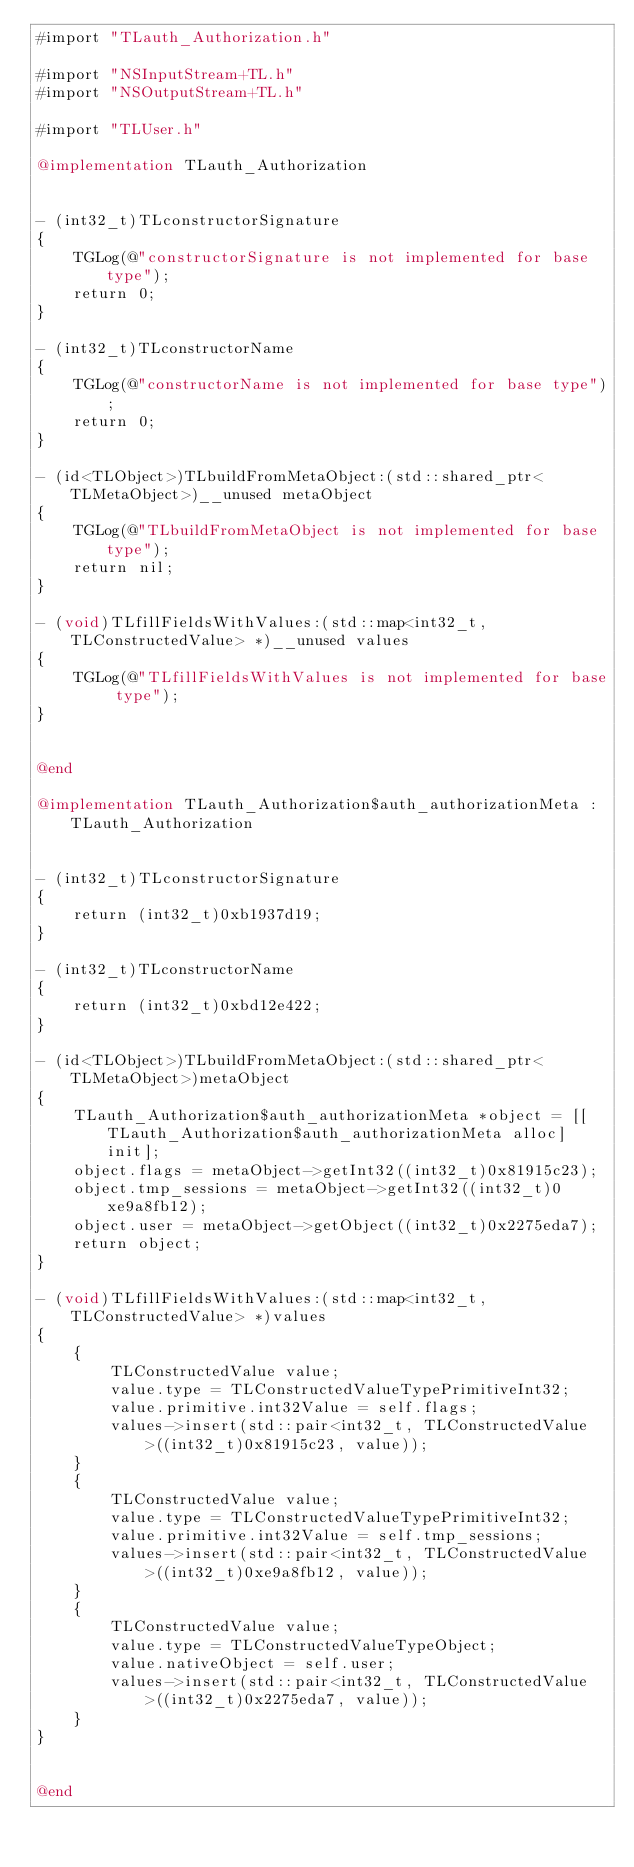Convert code to text. <code><loc_0><loc_0><loc_500><loc_500><_ObjectiveC_>#import "TLauth_Authorization.h"

#import "NSInputStream+TL.h"
#import "NSOutputStream+TL.h"

#import "TLUser.h"

@implementation TLauth_Authorization


- (int32_t)TLconstructorSignature
{
    TGLog(@"constructorSignature is not implemented for base type");
    return 0;
}

- (int32_t)TLconstructorName
{
    TGLog(@"constructorName is not implemented for base type");
    return 0;
}

- (id<TLObject>)TLbuildFromMetaObject:(std::shared_ptr<TLMetaObject>)__unused metaObject
{
    TGLog(@"TLbuildFromMetaObject is not implemented for base type");
    return nil;
}

- (void)TLfillFieldsWithValues:(std::map<int32_t, TLConstructedValue> *)__unused values
{
    TGLog(@"TLfillFieldsWithValues is not implemented for base type");
}


@end

@implementation TLauth_Authorization$auth_authorizationMeta : TLauth_Authorization


- (int32_t)TLconstructorSignature
{
    return (int32_t)0xb1937d19;
}

- (int32_t)TLconstructorName
{
    return (int32_t)0xbd12e422;
}

- (id<TLObject>)TLbuildFromMetaObject:(std::shared_ptr<TLMetaObject>)metaObject
{
    TLauth_Authorization$auth_authorizationMeta *object = [[TLauth_Authorization$auth_authorizationMeta alloc] init];
    object.flags = metaObject->getInt32((int32_t)0x81915c23);
    object.tmp_sessions = metaObject->getInt32((int32_t)0xe9a8fb12);
    object.user = metaObject->getObject((int32_t)0x2275eda7);
    return object;
}

- (void)TLfillFieldsWithValues:(std::map<int32_t, TLConstructedValue> *)values
{
    {
        TLConstructedValue value;
        value.type = TLConstructedValueTypePrimitiveInt32;
        value.primitive.int32Value = self.flags;
        values->insert(std::pair<int32_t, TLConstructedValue>((int32_t)0x81915c23, value));
    }
    {
        TLConstructedValue value;
        value.type = TLConstructedValueTypePrimitiveInt32;
        value.primitive.int32Value = self.tmp_sessions;
        values->insert(std::pair<int32_t, TLConstructedValue>((int32_t)0xe9a8fb12, value));
    }
    {
        TLConstructedValue value;
        value.type = TLConstructedValueTypeObject;
        value.nativeObject = self.user;
        values->insert(std::pair<int32_t, TLConstructedValue>((int32_t)0x2275eda7, value));
    }
}


@end

</code> 